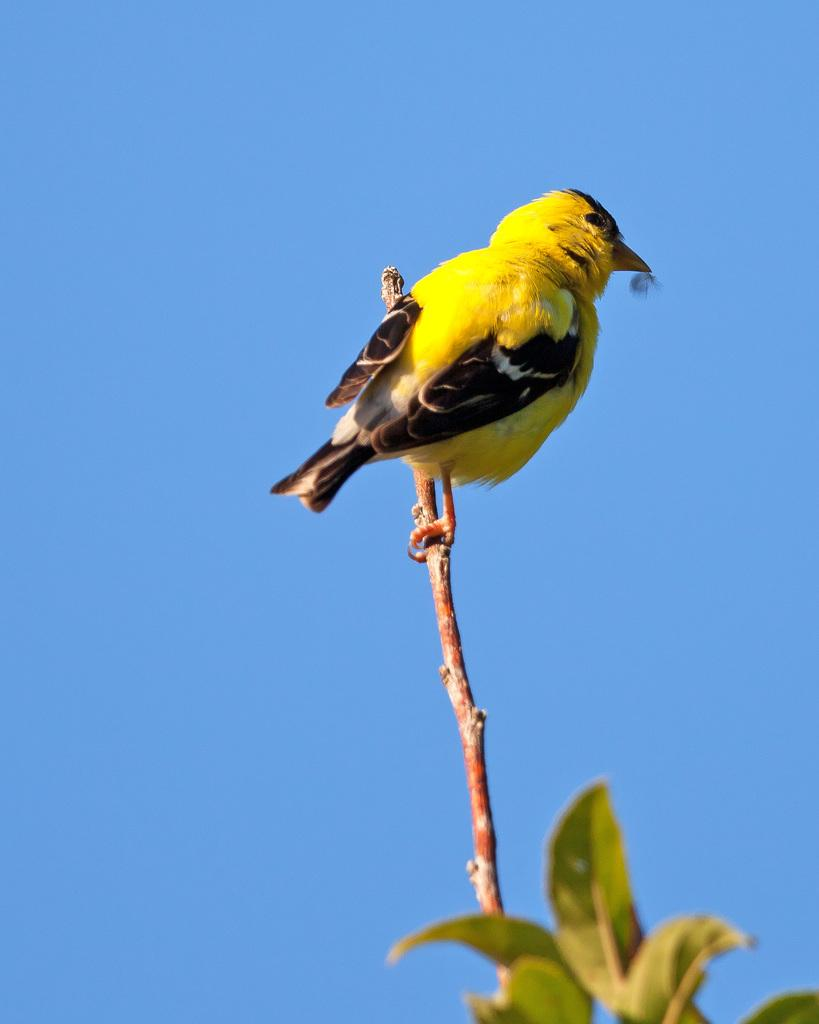What is the bird doing in the image? The bird is standing on a branch in the image. What type of vegetation is present in the image? Green leaves are visible in the image. What color is the sky in the image? The sky is blue in the image. What type of knowledge can be gained from the brass object in the image? There is no brass object present in the image, so no knowledge can be gained from it. 